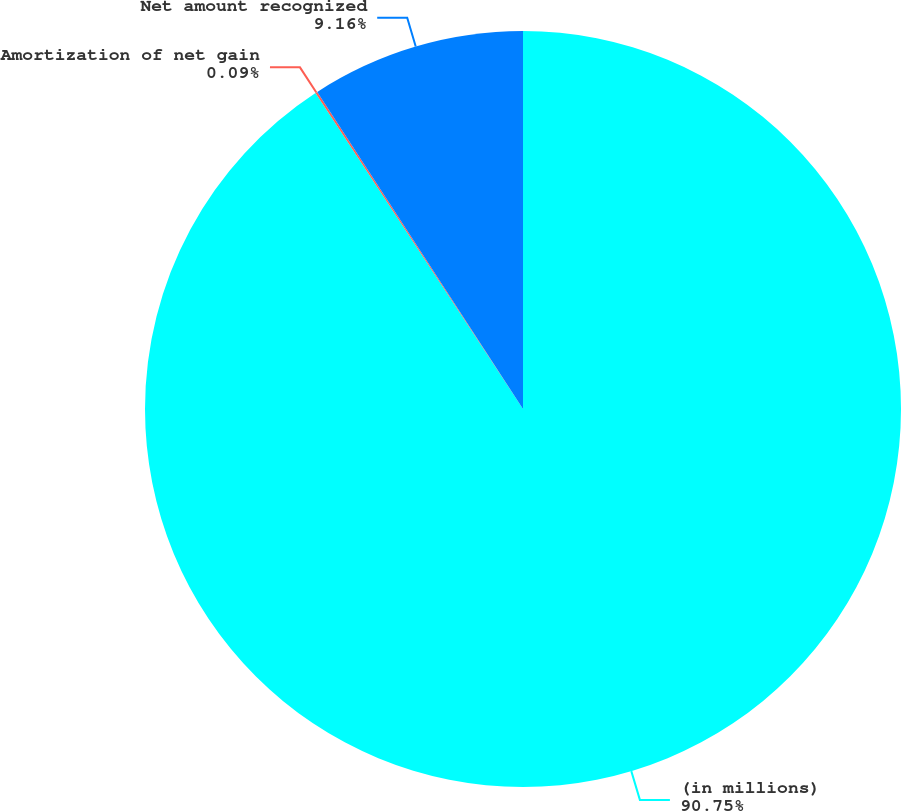<chart> <loc_0><loc_0><loc_500><loc_500><pie_chart><fcel>(in millions)<fcel>Amortization of net gain<fcel>Net amount recognized<nl><fcel>90.75%<fcel>0.09%<fcel>9.16%<nl></chart> 